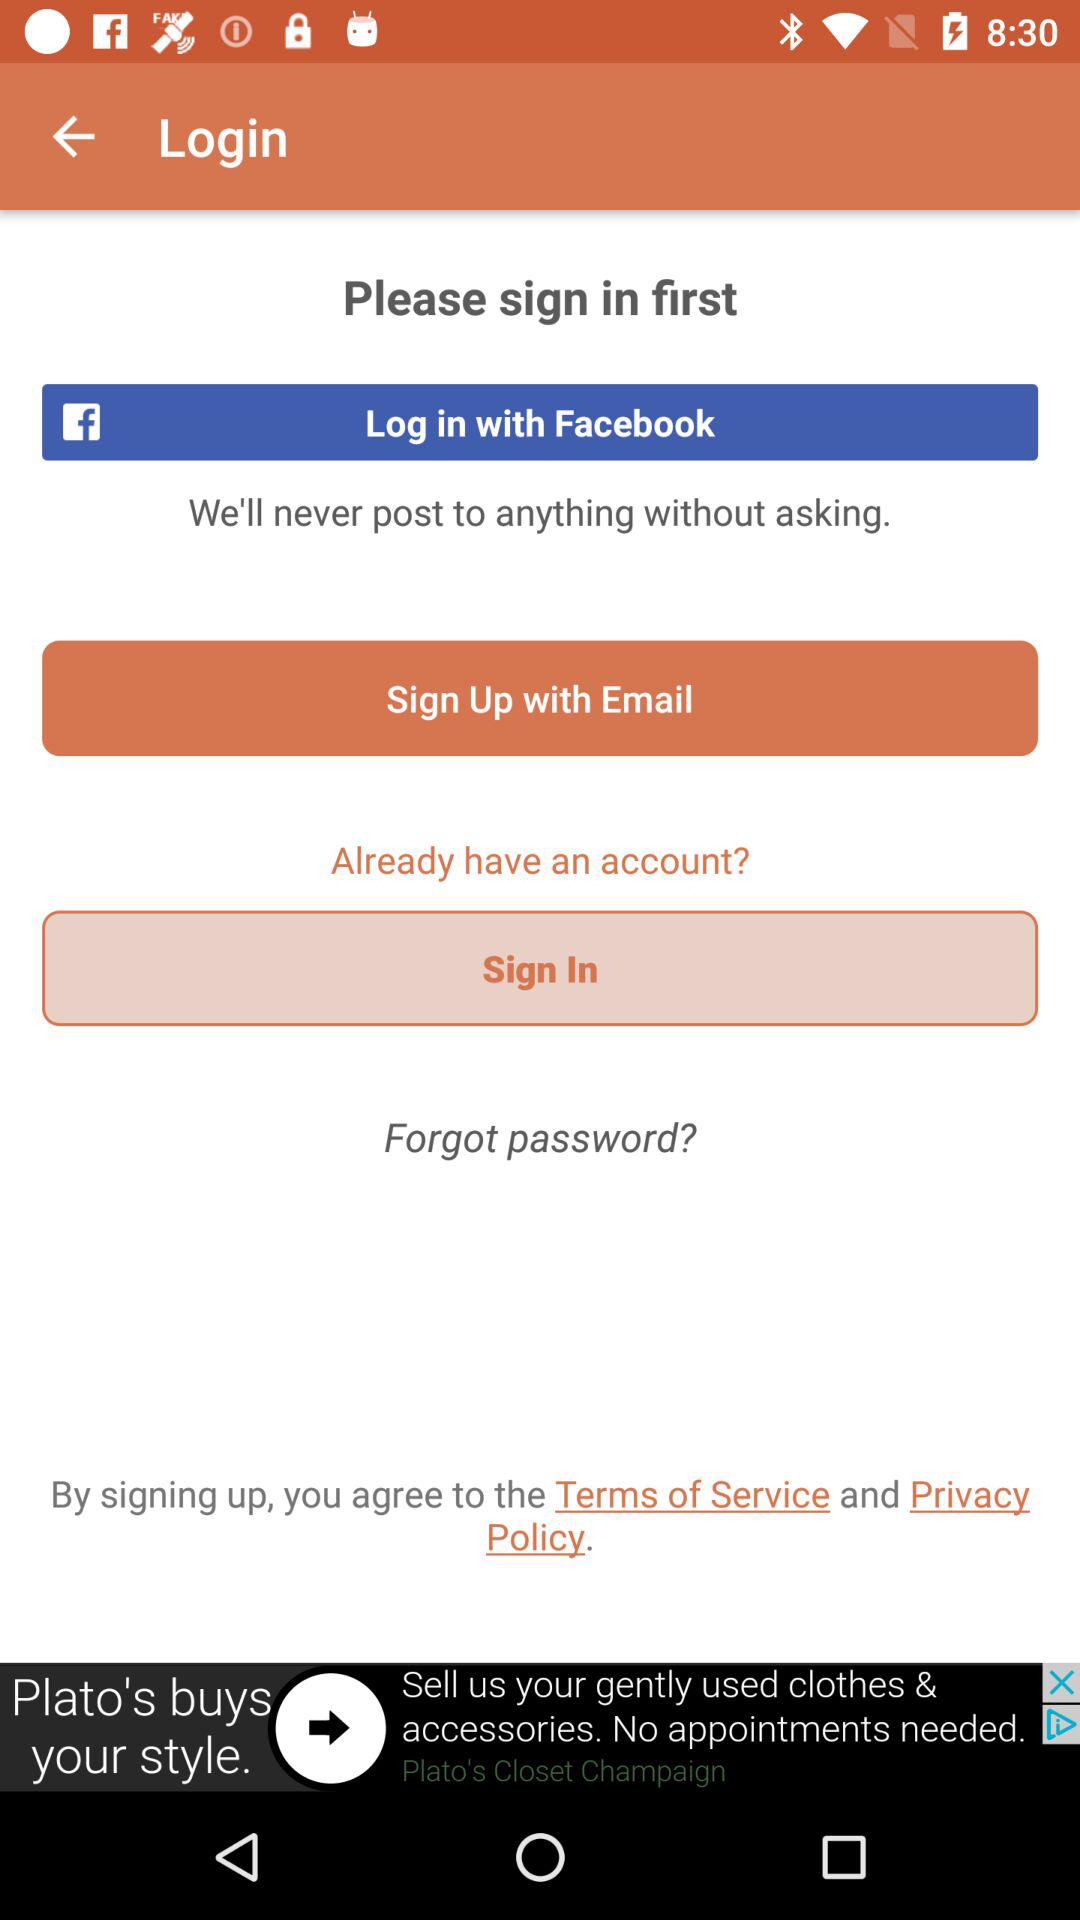Which account can I use to log in? You can use "Facebook" and "Email" accounts. 